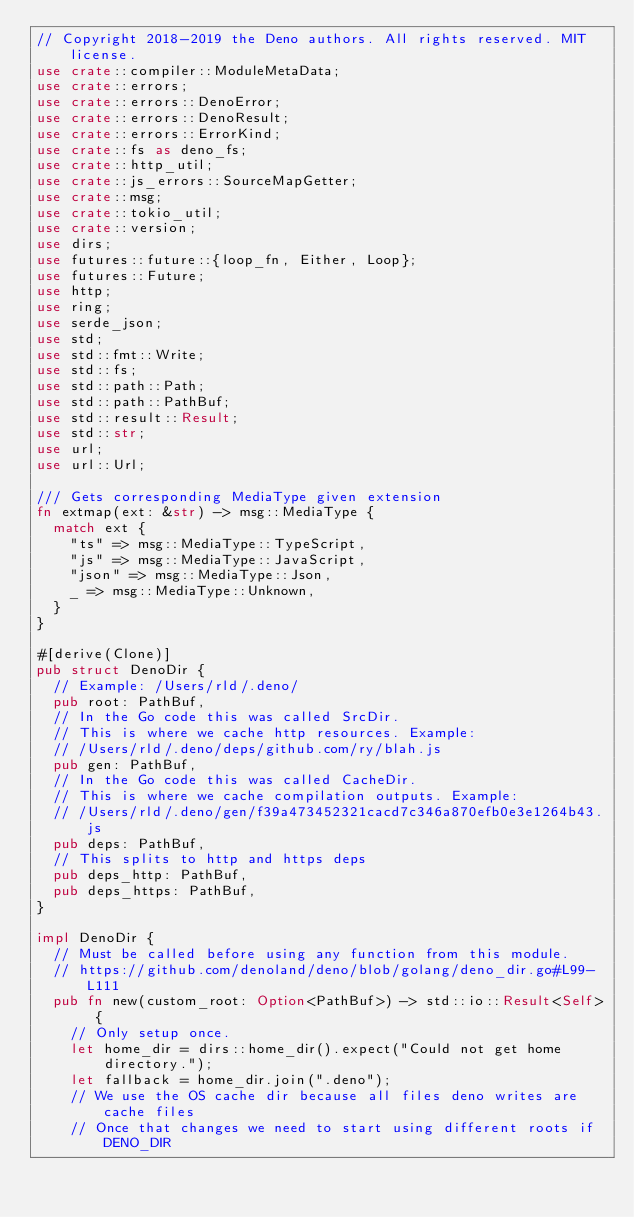<code> <loc_0><loc_0><loc_500><loc_500><_Rust_>// Copyright 2018-2019 the Deno authors. All rights reserved. MIT license.
use crate::compiler::ModuleMetaData;
use crate::errors;
use crate::errors::DenoError;
use crate::errors::DenoResult;
use crate::errors::ErrorKind;
use crate::fs as deno_fs;
use crate::http_util;
use crate::js_errors::SourceMapGetter;
use crate::msg;
use crate::tokio_util;
use crate::version;
use dirs;
use futures::future::{loop_fn, Either, Loop};
use futures::Future;
use http;
use ring;
use serde_json;
use std;
use std::fmt::Write;
use std::fs;
use std::path::Path;
use std::path::PathBuf;
use std::result::Result;
use std::str;
use url;
use url::Url;

/// Gets corresponding MediaType given extension
fn extmap(ext: &str) -> msg::MediaType {
  match ext {
    "ts" => msg::MediaType::TypeScript,
    "js" => msg::MediaType::JavaScript,
    "json" => msg::MediaType::Json,
    _ => msg::MediaType::Unknown,
  }
}

#[derive(Clone)]
pub struct DenoDir {
  // Example: /Users/rld/.deno/
  pub root: PathBuf,
  // In the Go code this was called SrcDir.
  // This is where we cache http resources. Example:
  // /Users/rld/.deno/deps/github.com/ry/blah.js
  pub gen: PathBuf,
  // In the Go code this was called CacheDir.
  // This is where we cache compilation outputs. Example:
  // /Users/rld/.deno/gen/f39a473452321cacd7c346a870efb0e3e1264b43.js
  pub deps: PathBuf,
  // This splits to http and https deps
  pub deps_http: PathBuf,
  pub deps_https: PathBuf,
}

impl DenoDir {
  // Must be called before using any function from this module.
  // https://github.com/denoland/deno/blob/golang/deno_dir.go#L99-L111
  pub fn new(custom_root: Option<PathBuf>) -> std::io::Result<Self> {
    // Only setup once.
    let home_dir = dirs::home_dir().expect("Could not get home directory.");
    let fallback = home_dir.join(".deno");
    // We use the OS cache dir because all files deno writes are cache files
    // Once that changes we need to start using different roots if DENO_DIR</code> 